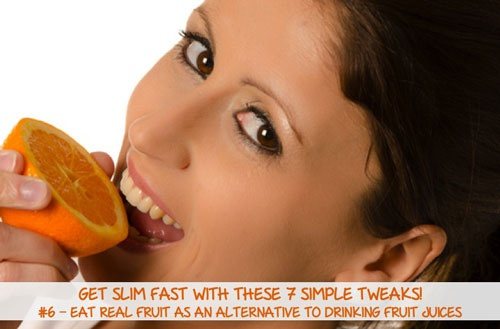Describe the objects in this image and their specific colors. I can see people in white, black, tan, brown, and salmon tones and orange in white, red, orange, and brown tones in this image. 